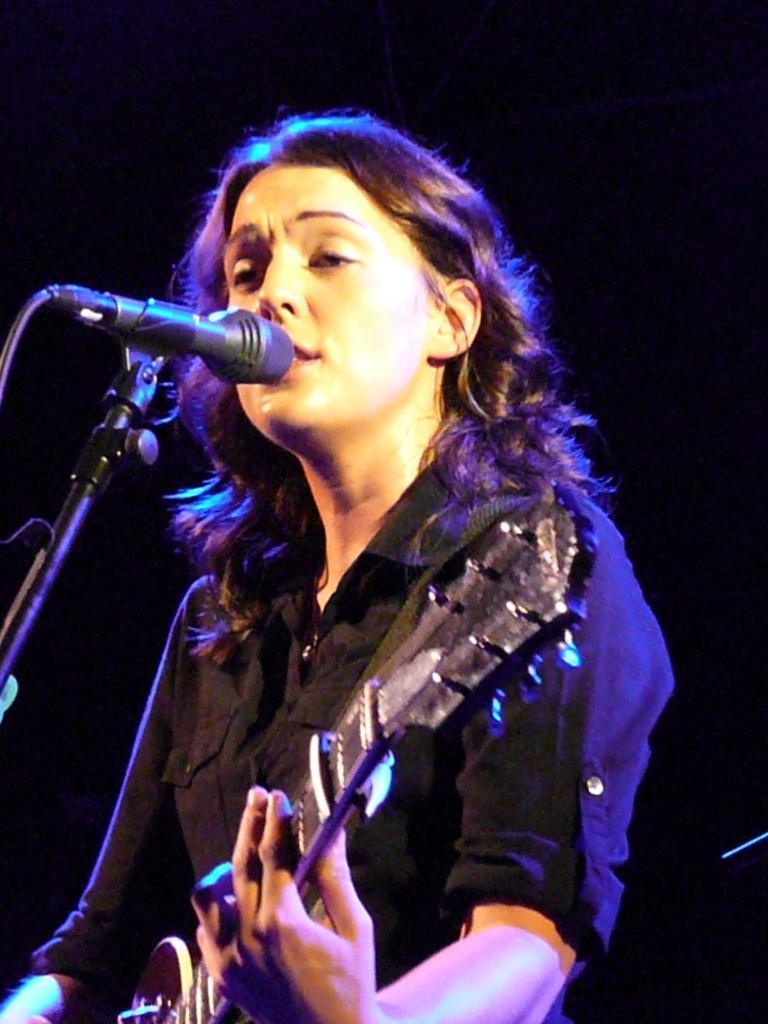Describe this image in one or two sentences. In the image we can see there is a woman standing and she is holding a guitar in her hand. In front of her there is a mic with a stand. 